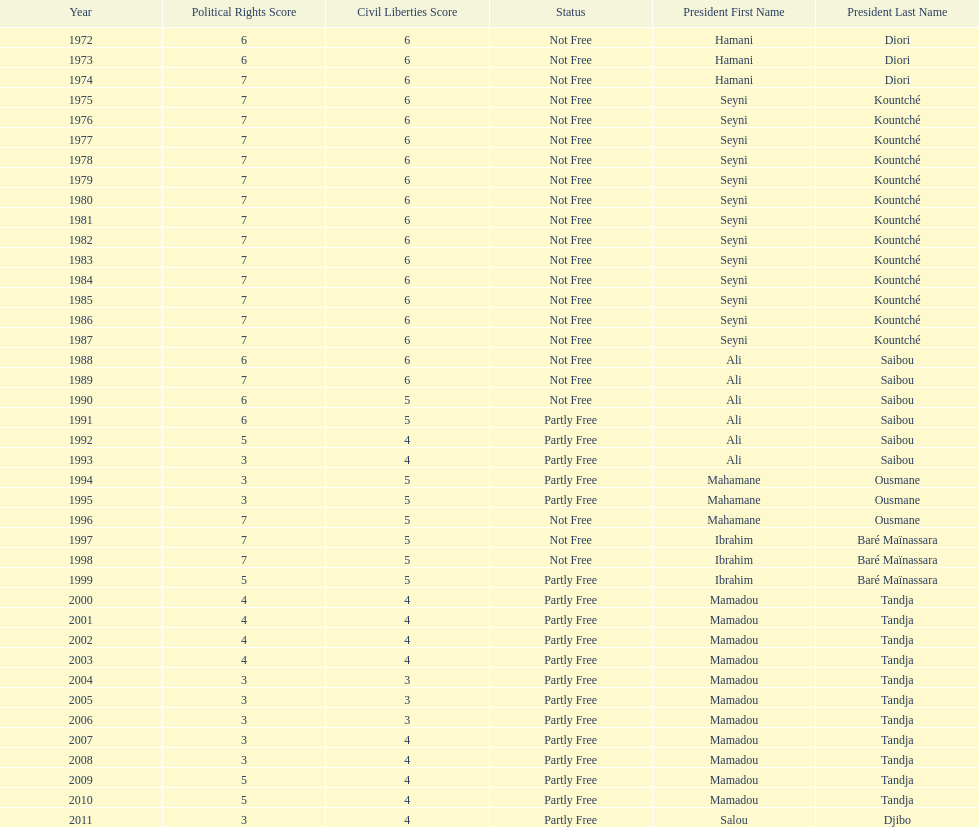How many years was it before the first partly free status? 18. 